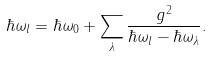<formula> <loc_0><loc_0><loc_500><loc_500>\hbar { \omega } _ { l } = \hbar { \omega } _ { 0 } + \sum _ { \lambda } \frac { g ^ { 2 } } { \hbar { \omega } _ { l } - \hbar { \omega } _ { \lambda } } .</formula> 